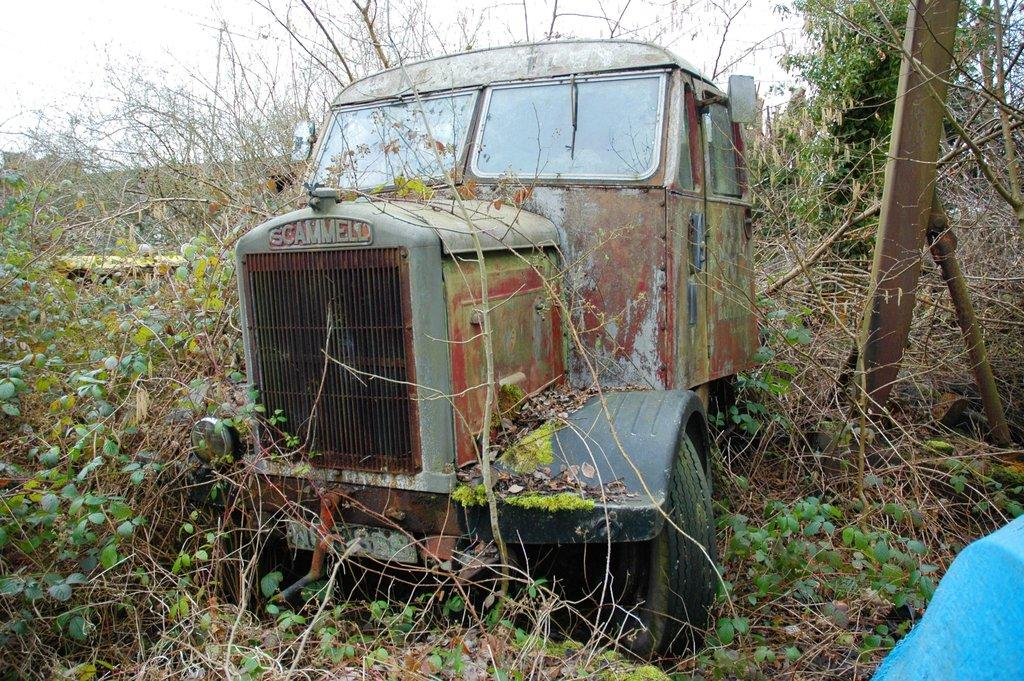What is located on the ground in the image? There is a vehicle on the ground in the image. What type of natural vegetation can be seen in the image? Trees are visible in the image. What part of the natural environment is visible in the background of the image? The sky is visible in the background of the image. How many cherries are hanging from the vehicle in the image? There are no cherries present in the image, and therefore no such activity can be observed. 